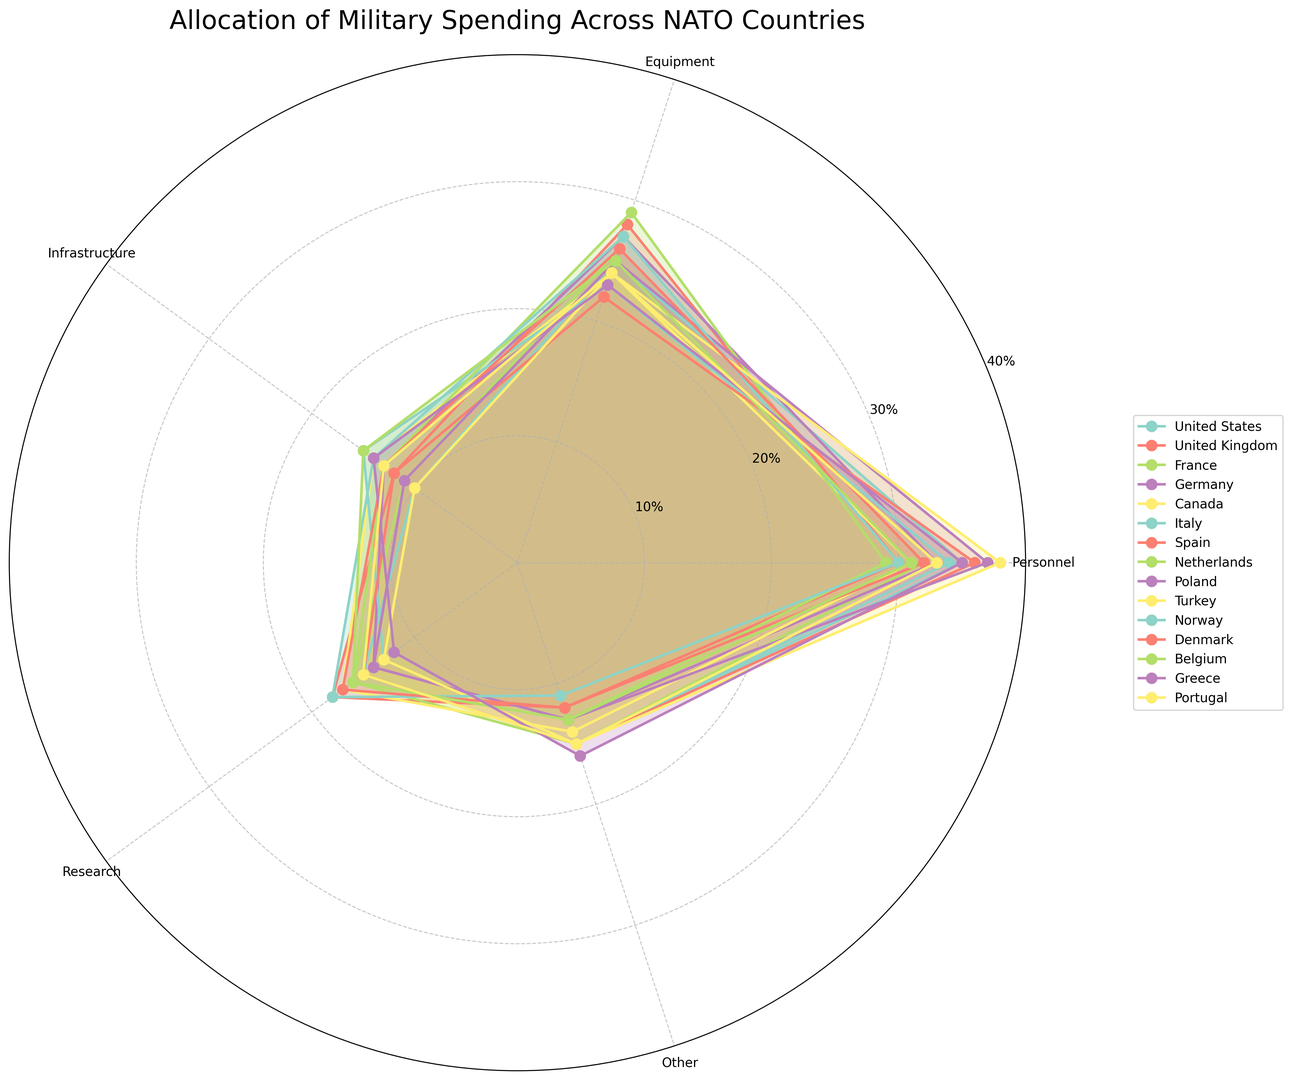Which country allocates the highest percentage to Personnel? By examining the length of the segments representing Personnel allocation in the chart, we see that Turkey has the longest segment for Personnel.
Answer: Turkey Which country spends more on Research, the United Kingdom or Germany? The segment for Research in the United Kingdom is longer compared to the segment for Germany.
Answer: United Kingdom Which two countries have equal allocation percentages in the Infrastructure category? Looking at the lengths of the segments for Infrastructure, both Belgium and Italy have segments of equal length in this category.
Answer: Belgium and Italy Compare the percentages allocated to Equipment between Spain and the Netherlands. Which one spends more? The segment for Equipment in the Netherlands is longer than the segment for Spain.
Answer: Netherlands Which three countries allocate the most to Other, Research, and Infrastructure categories combined? Summing up the segments for Other, Research, and Infrastructure, we find that the United Kingdom, Norway, and Netherlands have longer combined segments in these categories.
Answer: United Kingdom, Norway, Netherlands 